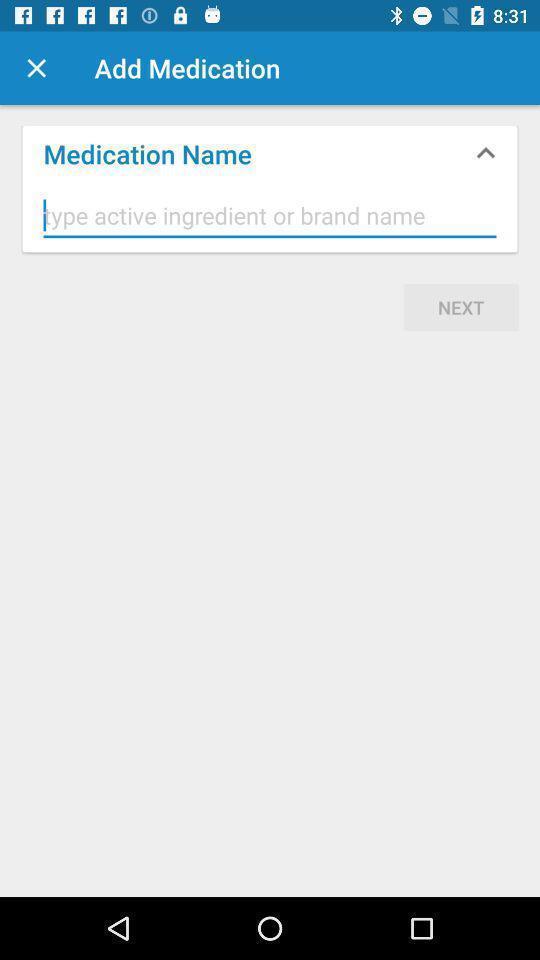Give me a summary of this screen capture. Page showing option to add medication. 